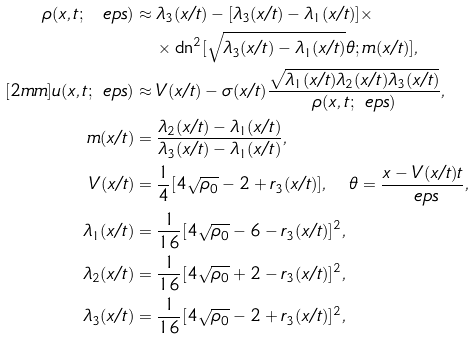Convert formula to latex. <formula><loc_0><loc_0><loc_500><loc_500>\rho ( x , t ; \ e p s ) & \approx \lambda _ { 3 } ( x / t ) - [ \lambda _ { 3 } ( x / t ) - \lambda _ { 1 } ( x / t ) ] \times \\ & \quad \times \text {dn} ^ { 2 } [ \sqrt { \lambda _ { 3 } ( x / t ) - \lambda _ { 1 } ( x / t ) } \theta ; m ( x / t ) ] , \\ [ 2 m m ] u ( x , t ; \ e p s ) & \approx V ( x / t ) - \sigma ( x / t ) \frac { \sqrt { \lambda _ { 1 } ( x / t ) \lambda _ { 2 } ( x / t ) \lambda _ { 3 } ( x / t ) } } { \rho ( x , t ; \ e p s ) } , \\ m ( x / t ) & = \frac { \lambda _ { 2 } ( x / t ) - \lambda _ { 1 } ( x / t ) } { \lambda _ { 3 } ( x / t ) - \lambda _ { 1 } ( x / t ) } , \\ V ( x / t ) & = \frac { 1 } { 4 } [ 4 \sqrt { \rho _ { 0 } } - 2 + r _ { 3 } ( x / t ) ] , \quad \theta = \frac { x - V ( x / t ) t } { \ e p s } , \\ \lambda _ { 1 } ( x / t ) & = \frac { 1 } { 1 6 } [ 4 \sqrt { \rho _ { 0 } } - 6 - r _ { 3 } ( x / t ) ] ^ { 2 } , \\ \lambda _ { 2 } ( x / t ) & = \frac { 1 } { 1 6 } [ 4 \sqrt { \rho _ { 0 } } + 2 - r _ { 3 } ( x / t ) ] ^ { 2 } , \\ \lambda _ { 3 } ( x / t ) & = \frac { 1 } { 1 6 } [ 4 \sqrt { \rho _ { 0 } } - 2 + r _ { 3 } ( x / t ) ] ^ { 2 } ,</formula> 